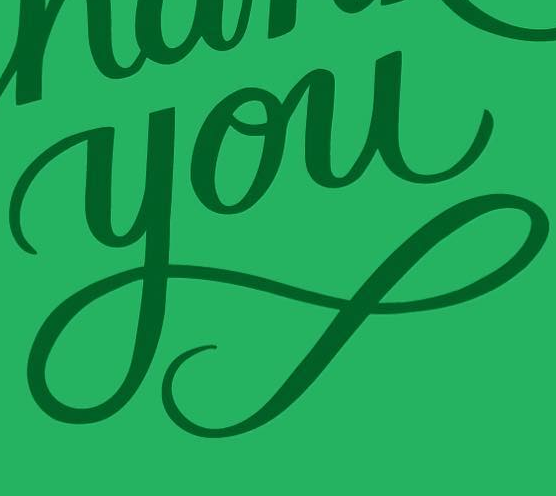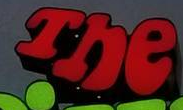Transcribe the words shown in these images in order, separated by a semicolon. you; The 